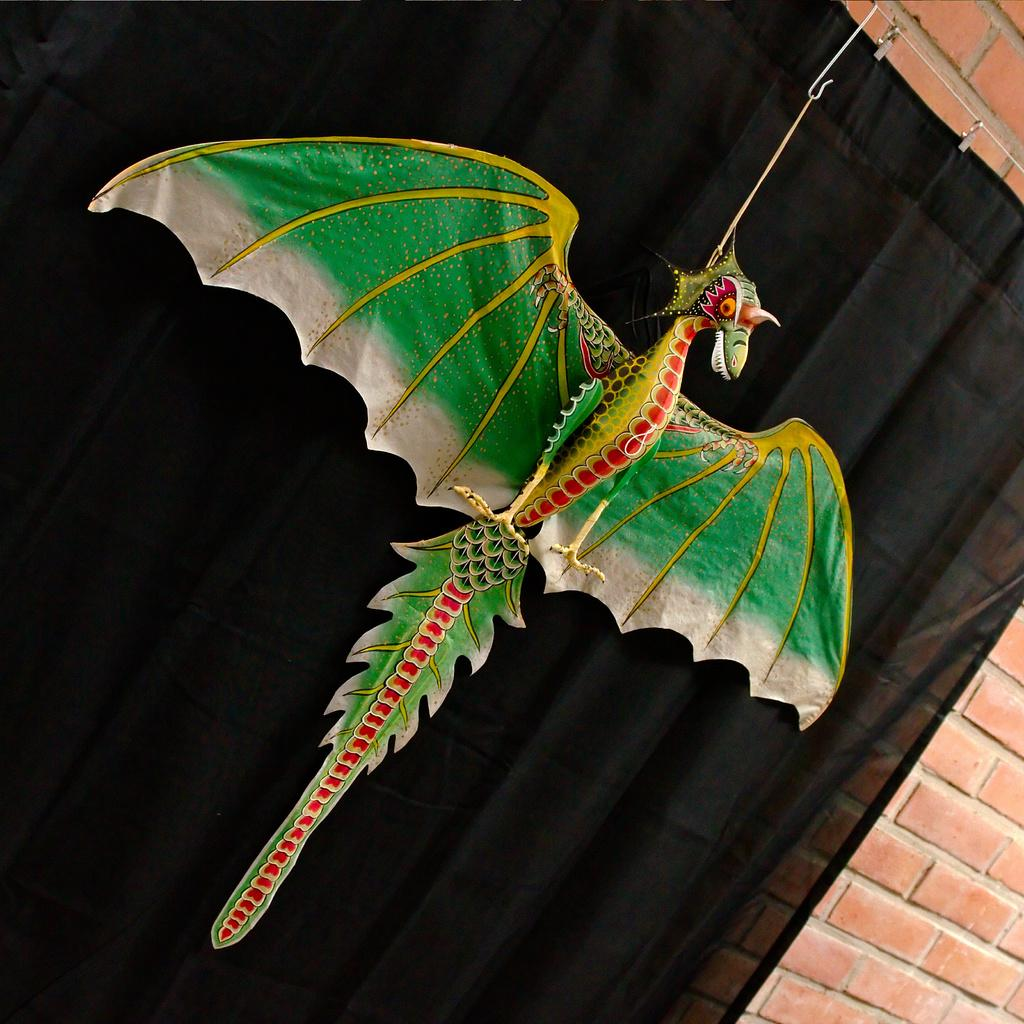What is hanging on a rope in the image? There is a toy animal hanging on a rope in the image. How is the rope connected to the toy animal? The rope is attached to a metal, which is likely holding the toy animal. What can be seen behind the toy animal? There is a curtain in the image. What are the clips used for in the image? The clips are present in the image, possibly to hold the curtain or other items. What type of surface is visible in the background? There is a wall in the image. What type of vegetable is being used as a whistle in the image? There is no vegetable or whistle present in the image. 